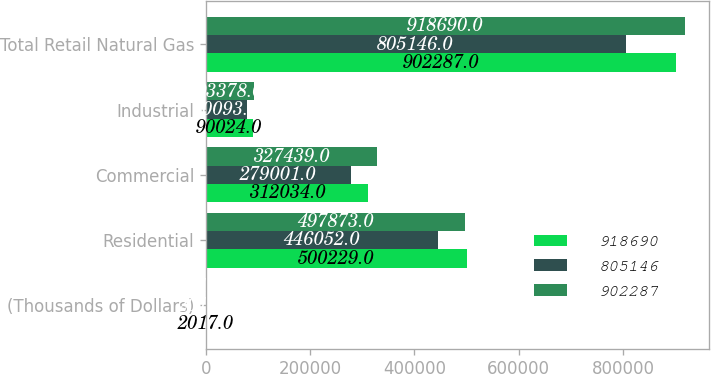Convert chart to OTSL. <chart><loc_0><loc_0><loc_500><loc_500><stacked_bar_chart><ecel><fcel>(Thousands of Dollars)<fcel>Residential<fcel>Commercial<fcel>Industrial<fcel>Total Retail Natural Gas<nl><fcel>918690<fcel>2017<fcel>500229<fcel>312034<fcel>90024<fcel>902287<nl><fcel>805146<fcel>2016<fcel>446052<fcel>279001<fcel>80093<fcel>805146<nl><fcel>902287<fcel>2015<fcel>497873<fcel>327439<fcel>93378<fcel>918690<nl></chart> 